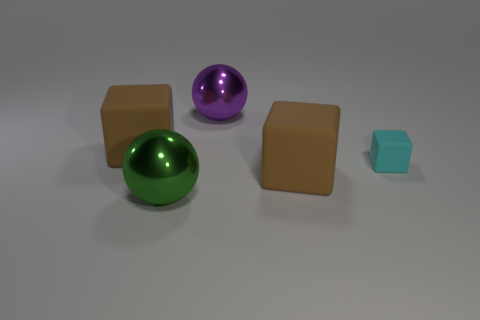Add 5 purple things. How many objects exist? 10 Subtract all spheres. How many objects are left? 3 Add 5 green shiny spheres. How many green shiny spheres exist? 6 Subtract 0 red cubes. How many objects are left? 5 Subtract all red matte objects. Subtract all large brown objects. How many objects are left? 3 Add 2 tiny cyan rubber blocks. How many tiny cyan rubber blocks are left? 3 